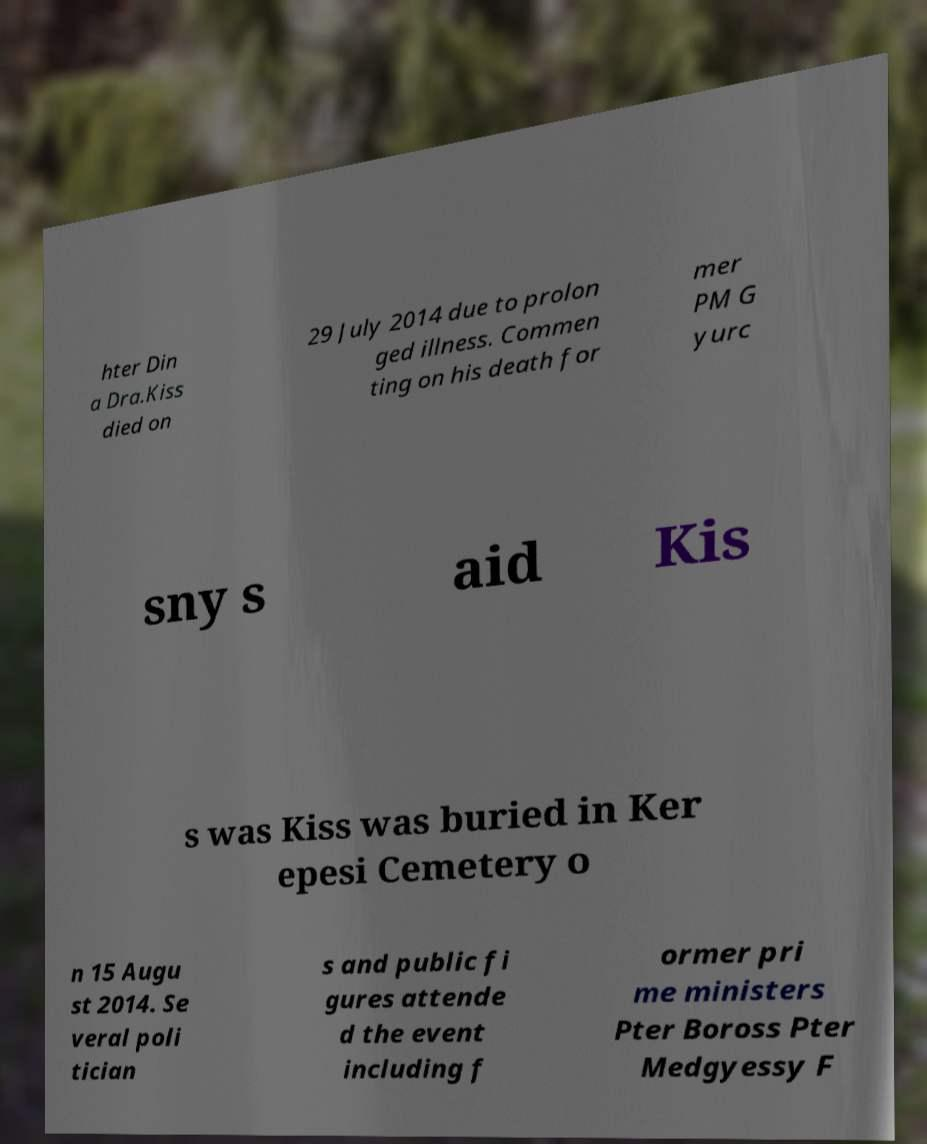For documentation purposes, I need the text within this image transcribed. Could you provide that? hter Din a Dra.Kiss died on 29 July 2014 due to prolon ged illness. Commen ting on his death for mer PM G yurc sny s aid Kis s was Kiss was buried in Ker epesi Cemetery o n 15 Augu st 2014. Se veral poli tician s and public fi gures attende d the event including f ormer pri me ministers Pter Boross Pter Medgyessy F 